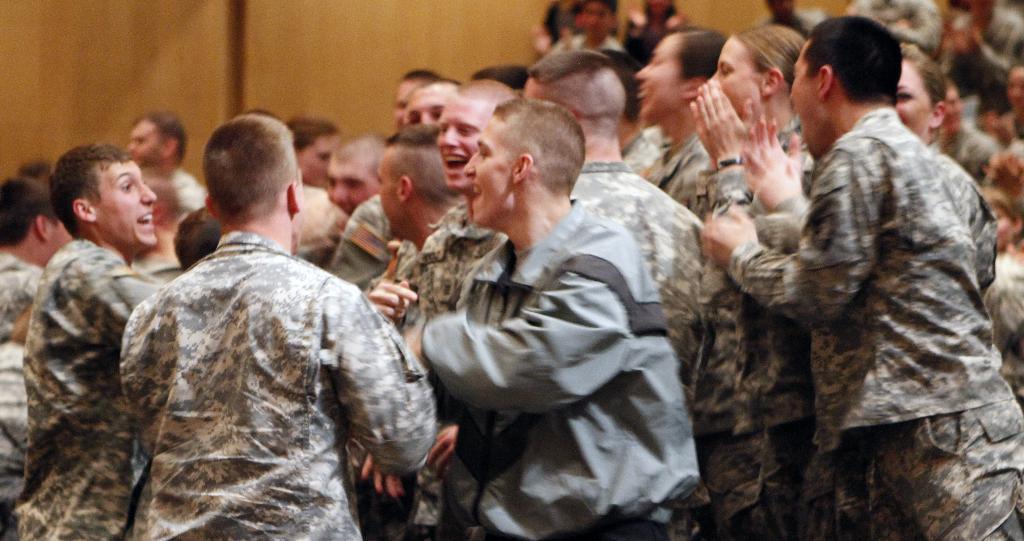Describe this image in one or two sentences. We can see group of people standing. Background we can see wooden wall. 